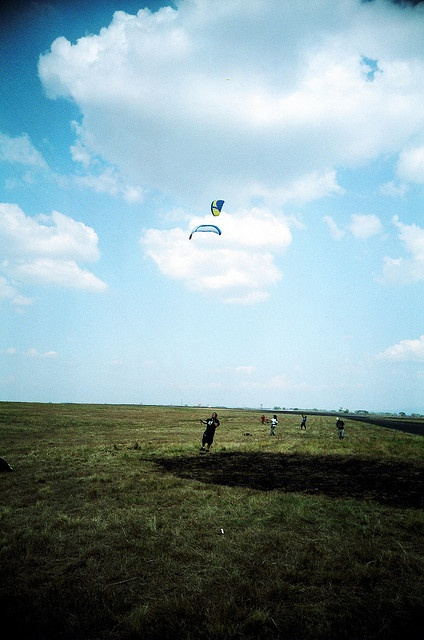Describe the objects in this image and their specific colors. I can see people in black, darkgreen, gray, and olive tones, kite in black, lightblue, and gray tones, kite in black, blue, navy, and khaki tones, people in black, teal, and darkgreen tones, and people in black, gray, lightblue, and darkgreen tones in this image. 